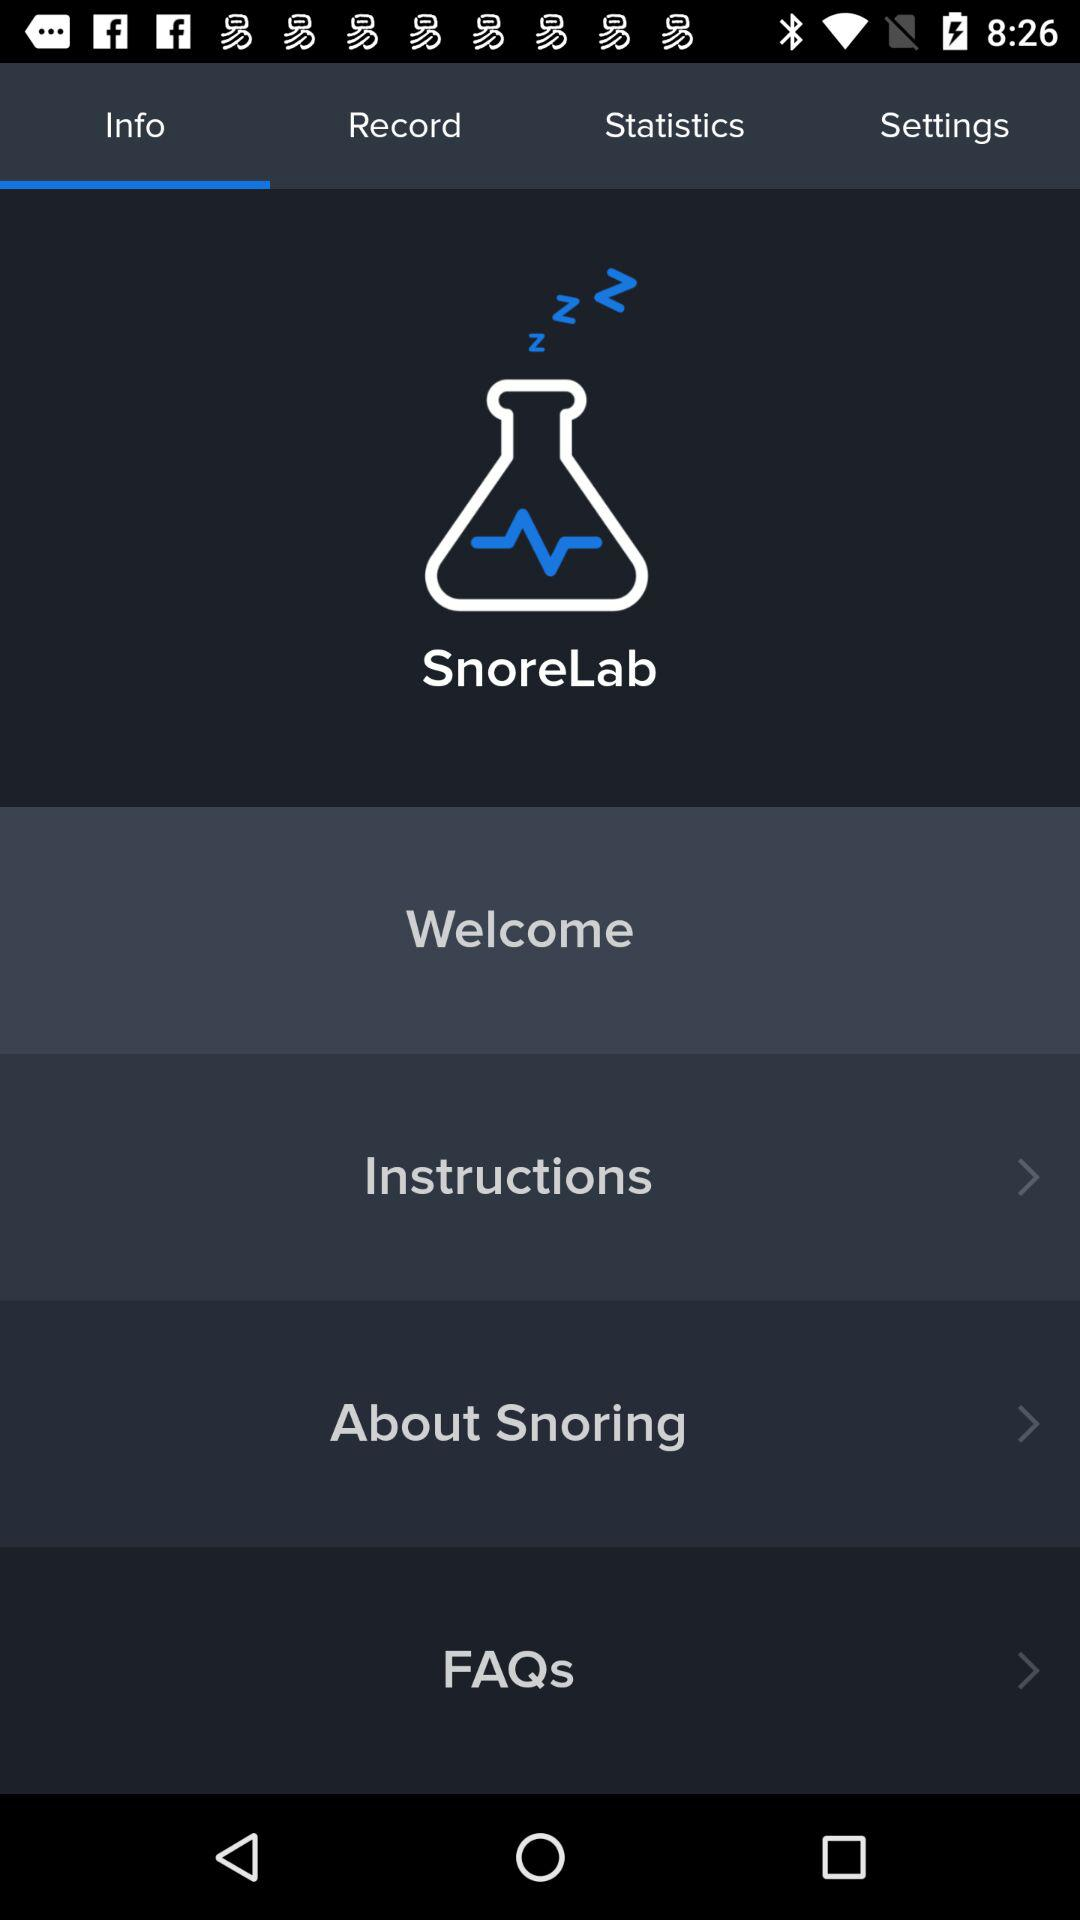What is the application name? The application name is "SnoreLab". 